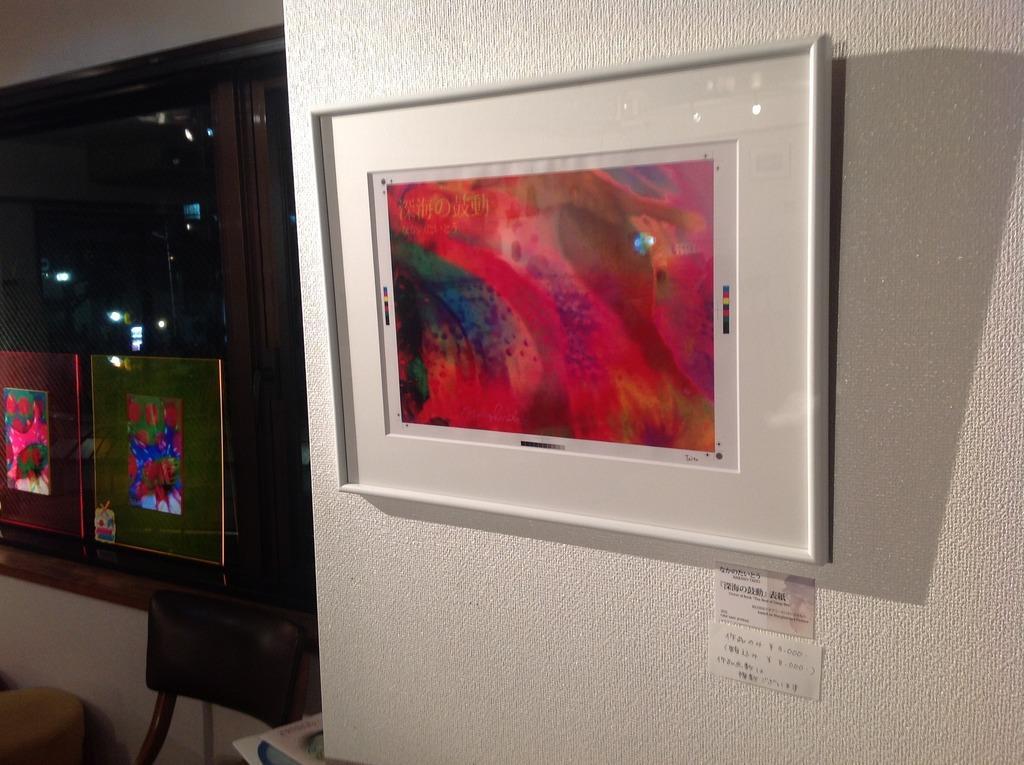Describe this image in one or two sentences. In the picture I can see a photo frame attached to the wall and there are few other photo frames,chair and a glass window in the left corner. 